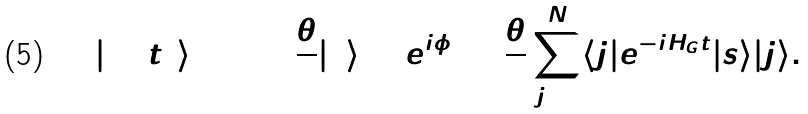Convert formula to latex. <formula><loc_0><loc_0><loc_500><loc_500>| \Psi ( t ) \rangle = \cos { \frac { \theta } { 2 } } | { 0 } \rangle + e ^ { i \phi } \sin { \frac { \theta } { 2 } } \sum _ { { j } = { 1 } } ^ { N } \langle { j } | e ^ { - i { H } _ { G } t } | { s } \rangle | { j } \rangle .</formula> 